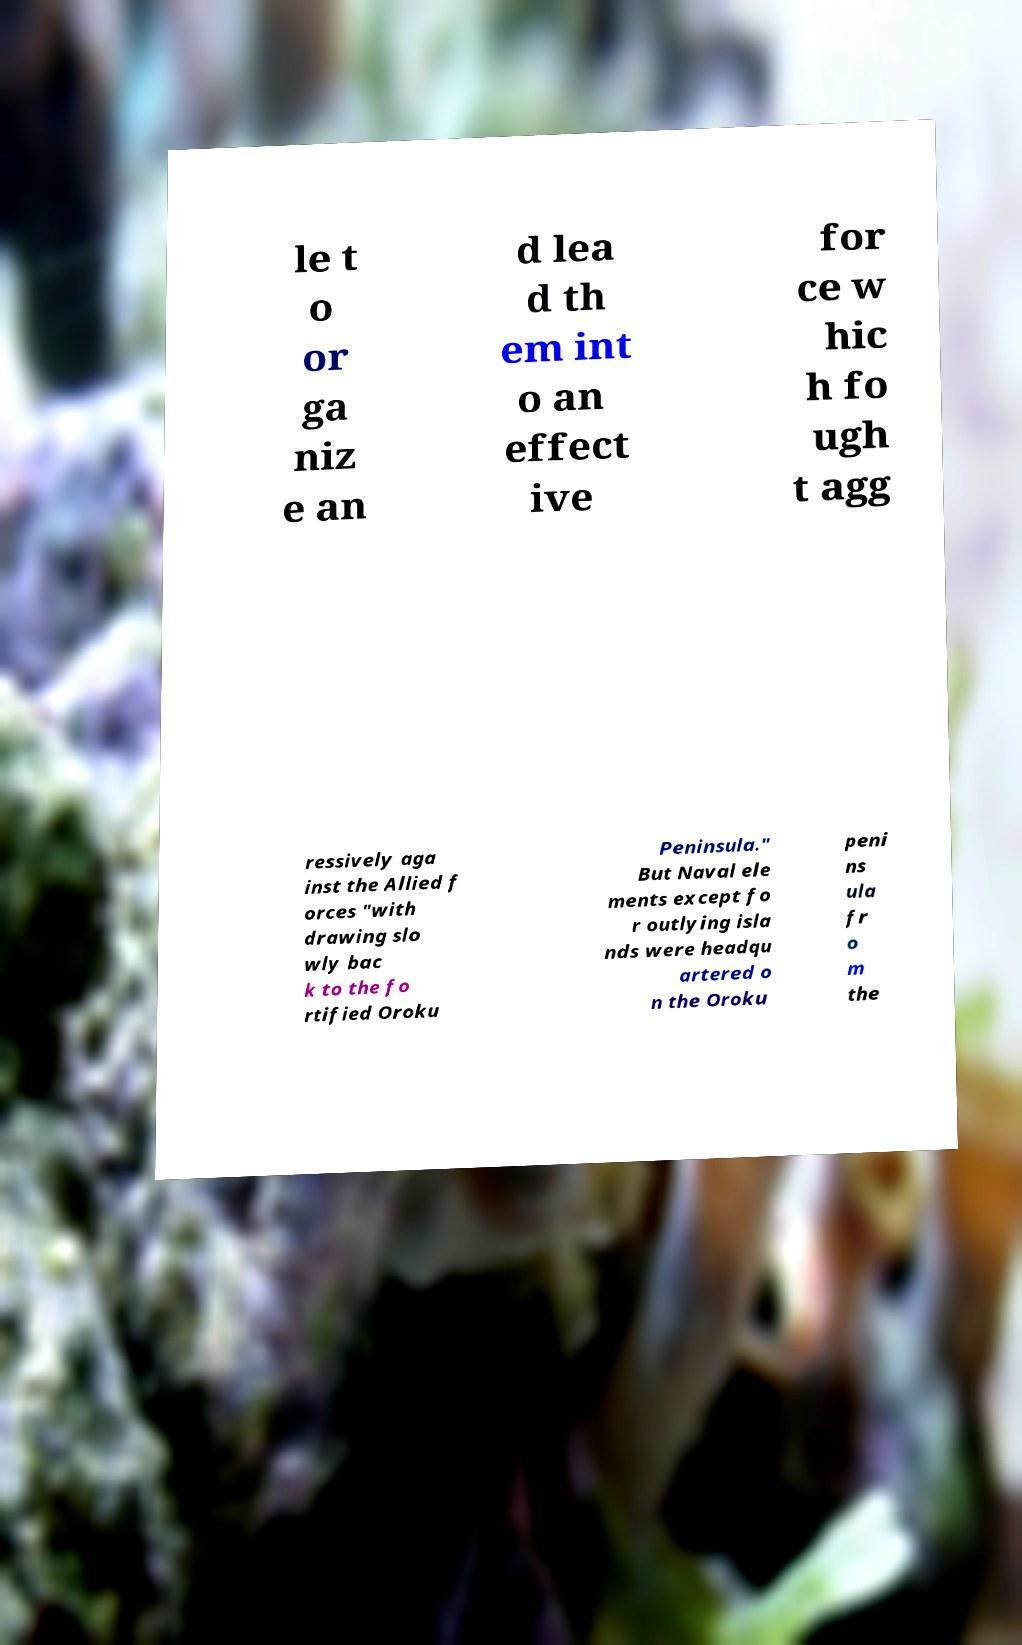Could you assist in decoding the text presented in this image and type it out clearly? le t o or ga niz e an d lea d th em int o an effect ive for ce w hic h fo ugh t agg ressively aga inst the Allied f orces "with drawing slo wly bac k to the fo rtified Oroku Peninsula." But Naval ele ments except fo r outlying isla nds were headqu artered o n the Oroku peni ns ula fr o m the 